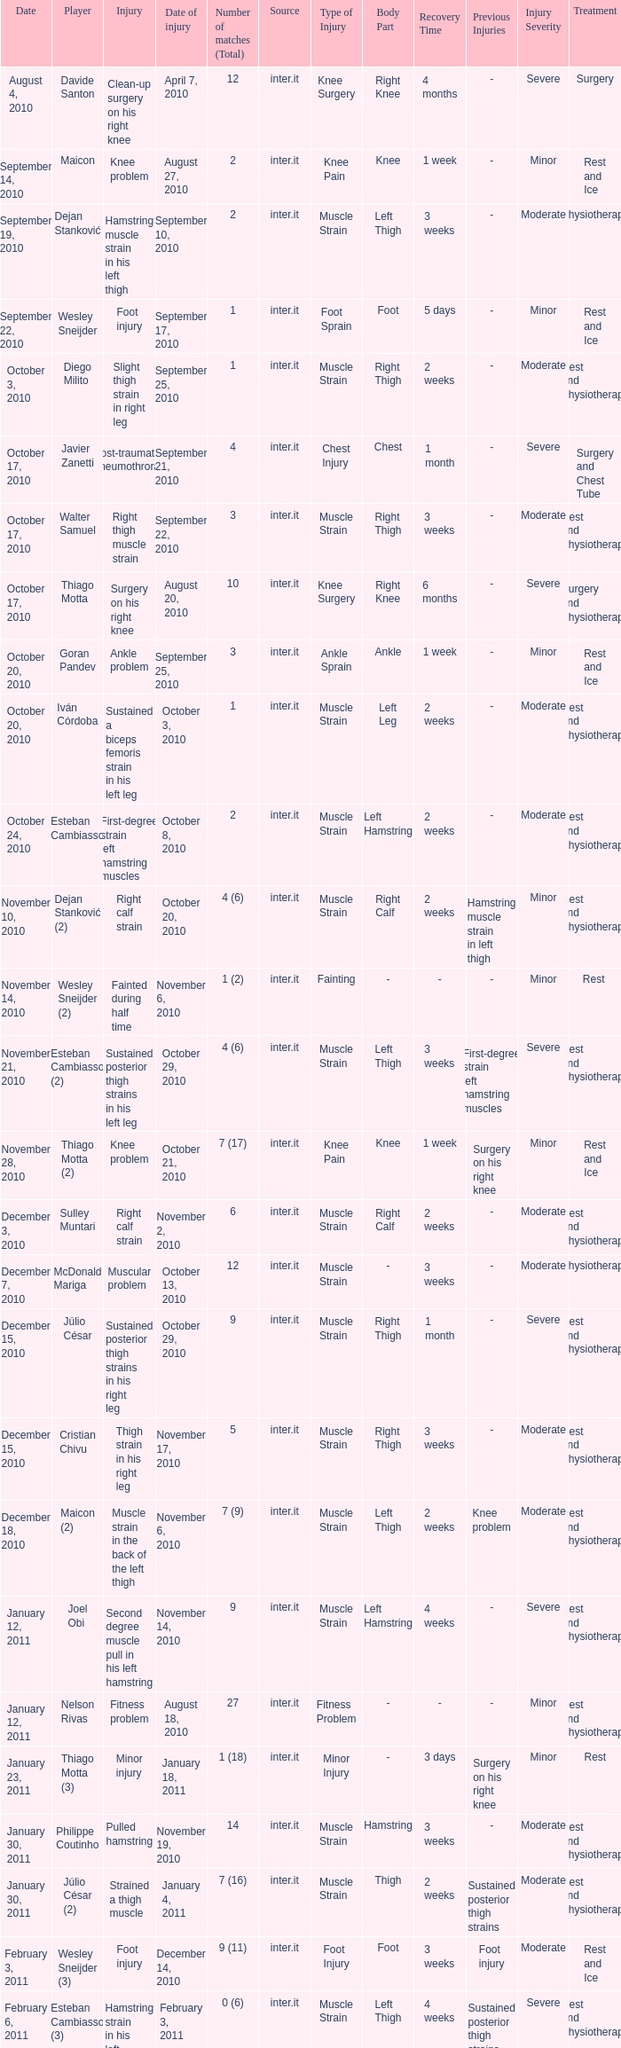What is the date of injury when the injury is foot injury and the number of matches (total) is 1? September 17, 2010. 